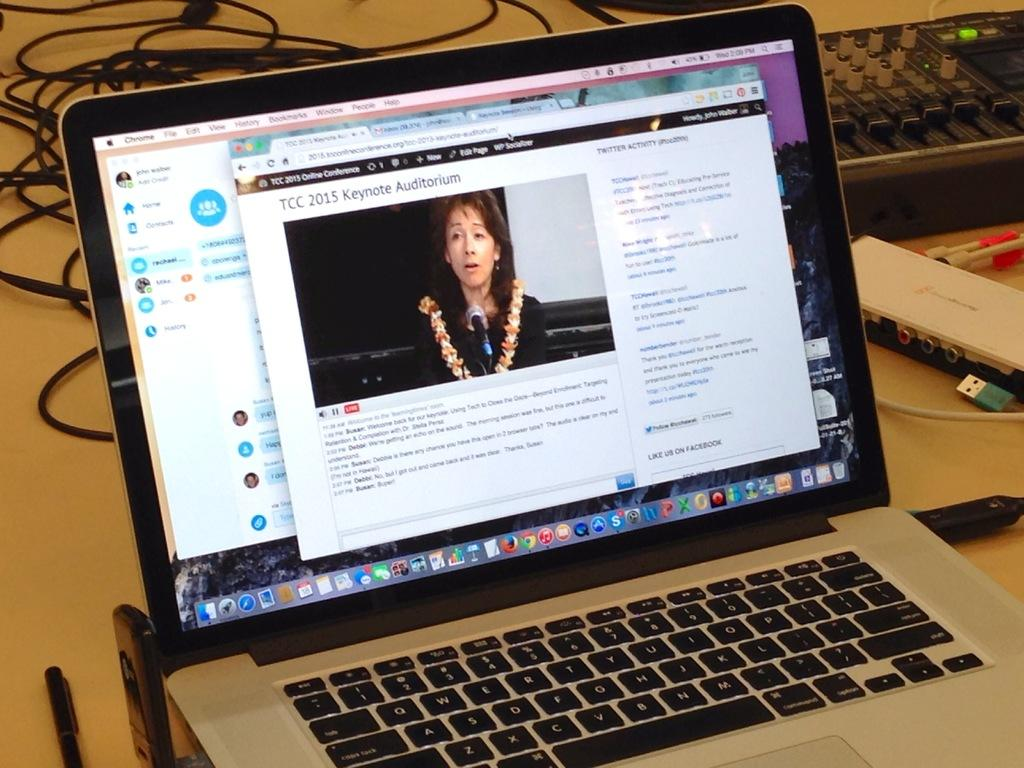<image>
Present a compact description of the photo's key features. Keyboard and Laptop that says TCC 2015 Keynote Auditorium on the top of the page. 